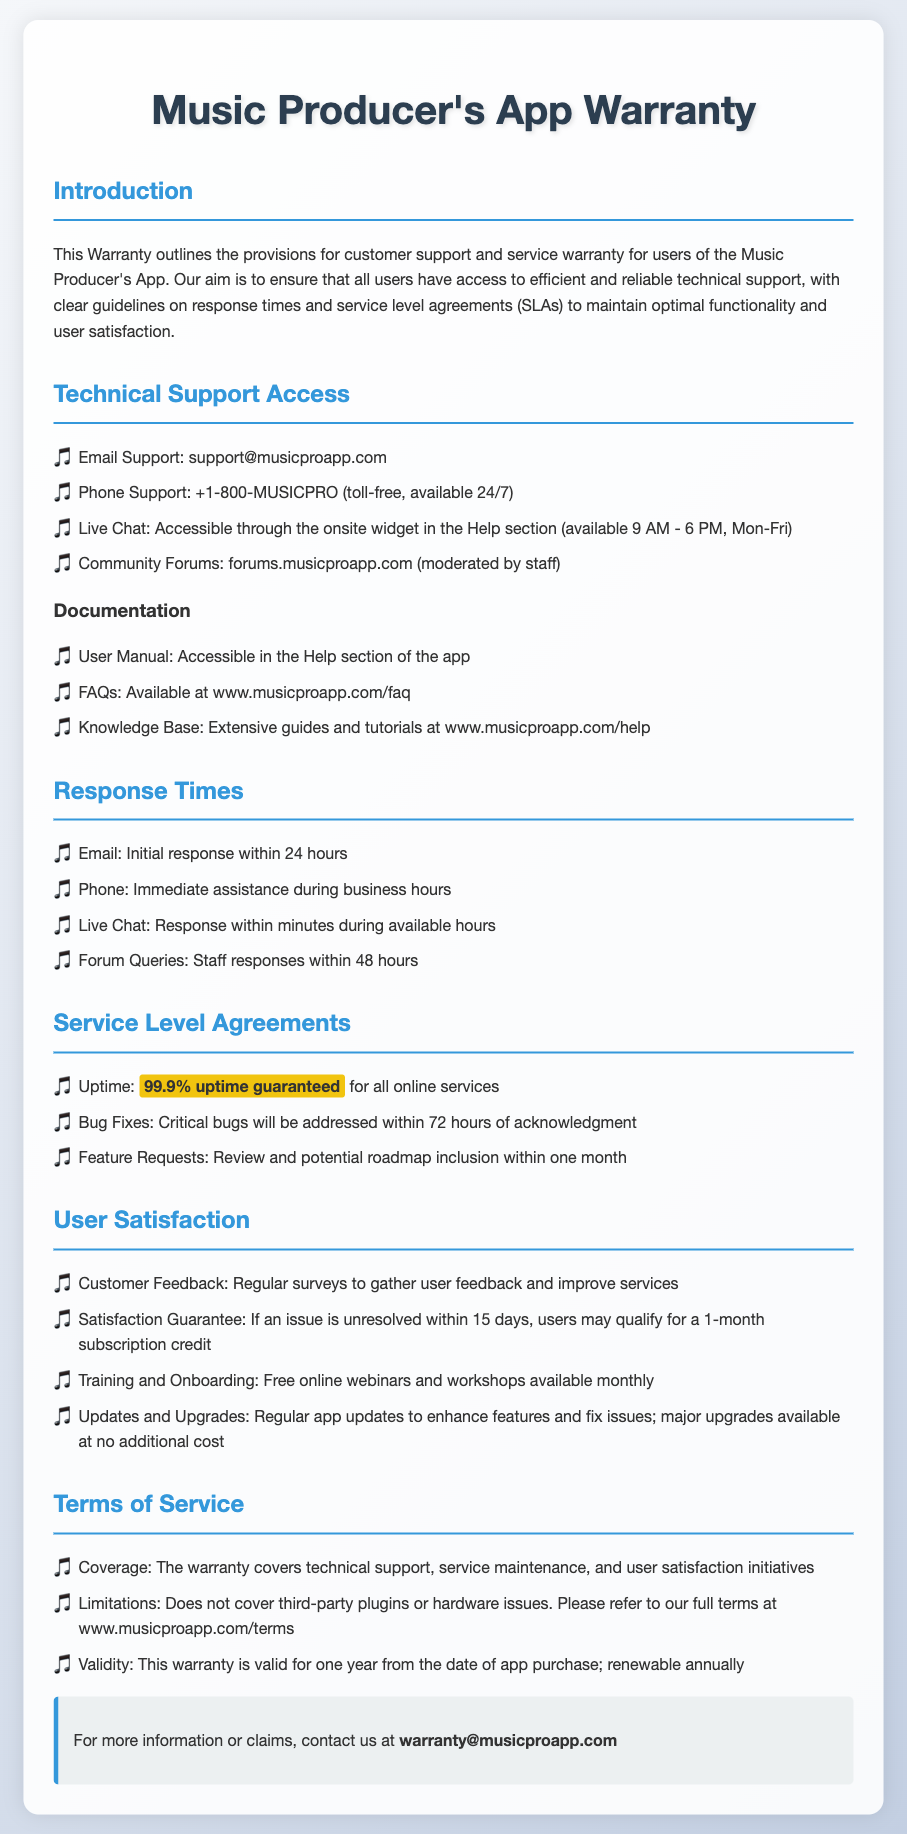What is the email for support? The document states that users can reach email support at support@musicproapp.com.
Answer: support@musicproapp.com What is the phone support availability? According to the document, phone support is available 24/7, making it easily accessible for users.
Answer: 24/7 What is the initial email response time? The document specifies that the initial response to an email inquiry will occur within 24 hours.
Answer: 24 hours How often are customer feedback surveys conducted? The document mentions that regular surveys are conducted to gather user feedback and improve services.
Answer: Regularly What is the guaranteed uptime for online services? The warranty guarantees an uptime of 99.9% for all online services.
Answer: 99.9% How long does it take to address critical bugs? The document states that critical bugs will be addressed within 72 hours of acknowledgment.
Answer: 72 hours What is the coverage of the warranty? The coverage of the warranty includes technical support, service maintenance, and user satisfaction initiatives.
Answer: Technical support, service maintenance, user satisfaction What happens if an issue is unresolved after 15 days? According to the warranty, users may qualify for a 1-month subscription credit if an issue remains unresolved after 15 days.
Answer: 1-month subscription credit What is the duration of the warranty validity? The document explains that the warranty is valid for one year from the date of app purchase and can be renewed annually.
Answer: One year 